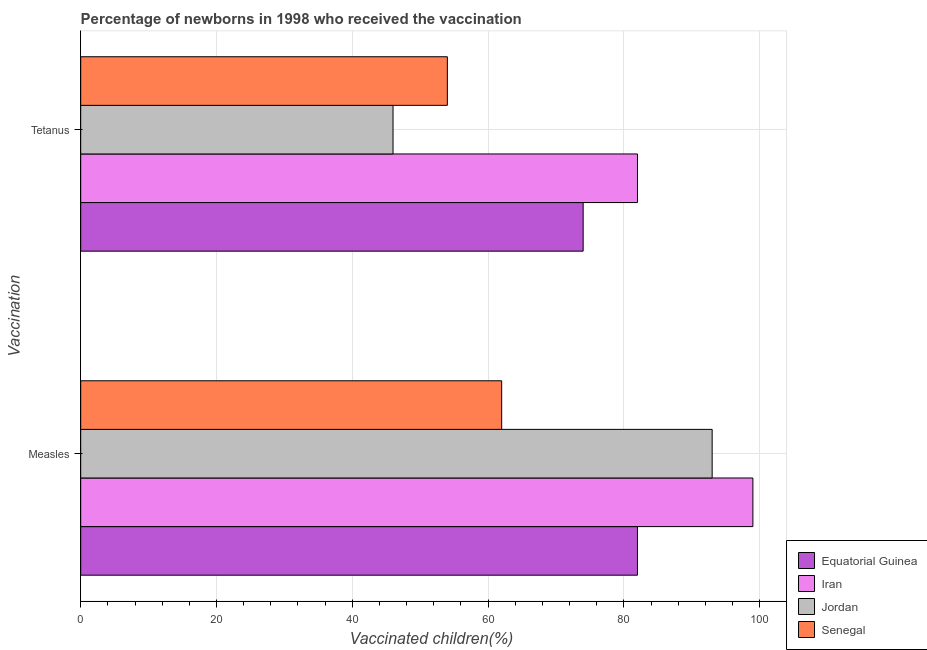What is the label of the 2nd group of bars from the top?
Ensure brevity in your answer.  Measles. What is the percentage of newborns who received vaccination for measles in Equatorial Guinea?
Keep it short and to the point. 82. Across all countries, what is the maximum percentage of newborns who received vaccination for measles?
Ensure brevity in your answer.  99. Across all countries, what is the minimum percentage of newborns who received vaccination for measles?
Keep it short and to the point. 62. In which country was the percentage of newborns who received vaccination for measles maximum?
Make the answer very short. Iran. In which country was the percentage of newborns who received vaccination for measles minimum?
Provide a short and direct response. Senegal. What is the total percentage of newborns who received vaccination for measles in the graph?
Provide a succinct answer. 336. What is the difference between the percentage of newborns who received vaccination for tetanus in Senegal and that in Equatorial Guinea?
Make the answer very short. -20. What is the difference between the percentage of newborns who received vaccination for tetanus in Jordan and the percentage of newborns who received vaccination for measles in Equatorial Guinea?
Make the answer very short. -36. What is the difference between the percentage of newborns who received vaccination for measles and percentage of newborns who received vaccination for tetanus in Iran?
Offer a very short reply. 17. In how many countries, is the percentage of newborns who received vaccination for measles greater than 24 %?
Offer a terse response. 4. What is the ratio of the percentage of newborns who received vaccination for tetanus in Equatorial Guinea to that in Jordan?
Your response must be concise. 1.61. What does the 2nd bar from the top in Measles represents?
Make the answer very short. Jordan. What does the 4th bar from the bottom in Measles represents?
Your answer should be very brief. Senegal. How many countries are there in the graph?
Your answer should be very brief. 4. Are the values on the major ticks of X-axis written in scientific E-notation?
Your response must be concise. No. Where does the legend appear in the graph?
Your answer should be compact. Bottom right. How many legend labels are there?
Keep it short and to the point. 4. What is the title of the graph?
Your response must be concise. Percentage of newborns in 1998 who received the vaccination. Does "World" appear as one of the legend labels in the graph?
Your answer should be compact. No. What is the label or title of the X-axis?
Keep it short and to the point. Vaccinated children(%)
. What is the label or title of the Y-axis?
Offer a terse response. Vaccination. What is the Vaccinated children(%)
 of Equatorial Guinea in Measles?
Offer a very short reply. 82. What is the Vaccinated children(%)
 in Jordan in Measles?
Your answer should be compact. 93. What is the Vaccinated children(%)
 in Senegal in Measles?
Keep it short and to the point. 62. What is the Vaccinated children(%)
 of Senegal in Tetanus?
Give a very brief answer. 54. Across all Vaccination, what is the maximum Vaccinated children(%)
 of Iran?
Make the answer very short. 99. Across all Vaccination, what is the maximum Vaccinated children(%)
 in Jordan?
Make the answer very short. 93. Across all Vaccination, what is the maximum Vaccinated children(%)
 in Senegal?
Your answer should be very brief. 62. Across all Vaccination, what is the minimum Vaccinated children(%)
 in Iran?
Your answer should be compact. 82. Across all Vaccination, what is the minimum Vaccinated children(%)
 of Senegal?
Offer a very short reply. 54. What is the total Vaccinated children(%)
 of Equatorial Guinea in the graph?
Your response must be concise. 156. What is the total Vaccinated children(%)
 in Iran in the graph?
Your response must be concise. 181. What is the total Vaccinated children(%)
 in Jordan in the graph?
Provide a short and direct response. 139. What is the total Vaccinated children(%)
 in Senegal in the graph?
Offer a terse response. 116. What is the difference between the Vaccinated children(%)
 of Equatorial Guinea in Measles and the Vaccinated children(%)
 of Jordan in Tetanus?
Provide a short and direct response. 36. What is the difference between the Vaccinated children(%)
 in Iran in Measles and the Vaccinated children(%)
 in Senegal in Tetanus?
Provide a short and direct response. 45. What is the average Vaccinated children(%)
 of Iran per Vaccination?
Keep it short and to the point. 90.5. What is the average Vaccinated children(%)
 of Jordan per Vaccination?
Give a very brief answer. 69.5. What is the average Vaccinated children(%)
 in Senegal per Vaccination?
Your answer should be very brief. 58. What is the difference between the Vaccinated children(%)
 of Equatorial Guinea and Vaccinated children(%)
 of Senegal in Measles?
Make the answer very short. 20. What is the difference between the Vaccinated children(%)
 in Equatorial Guinea and Vaccinated children(%)
 in Jordan in Tetanus?
Provide a succinct answer. 28. What is the difference between the Vaccinated children(%)
 of Iran and Vaccinated children(%)
 of Jordan in Tetanus?
Make the answer very short. 36. What is the difference between the Vaccinated children(%)
 of Iran and Vaccinated children(%)
 of Senegal in Tetanus?
Make the answer very short. 28. What is the ratio of the Vaccinated children(%)
 of Equatorial Guinea in Measles to that in Tetanus?
Give a very brief answer. 1.11. What is the ratio of the Vaccinated children(%)
 of Iran in Measles to that in Tetanus?
Provide a short and direct response. 1.21. What is the ratio of the Vaccinated children(%)
 in Jordan in Measles to that in Tetanus?
Make the answer very short. 2.02. What is the ratio of the Vaccinated children(%)
 in Senegal in Measles to that in Tetanus?
Offer a terse response. 1.15. What is the difference between the highest and the second highest Vaccinated children(%)
 of Equatorial Guinea?
Provide a succinct answer. 8. What is the difference between the highest and the second highest Vaccinated children(%)
 in Iran?
Give a very brief answer. 17. What is the difference between the highest and the lowest Vaccinated children(%)
 in Equatorial Guinea?
Keep it short and to the point. 8. What is the difference between the highest and the lowest Vaccinated children(%)
 in Jordan?
Make the answer very short. 47. 